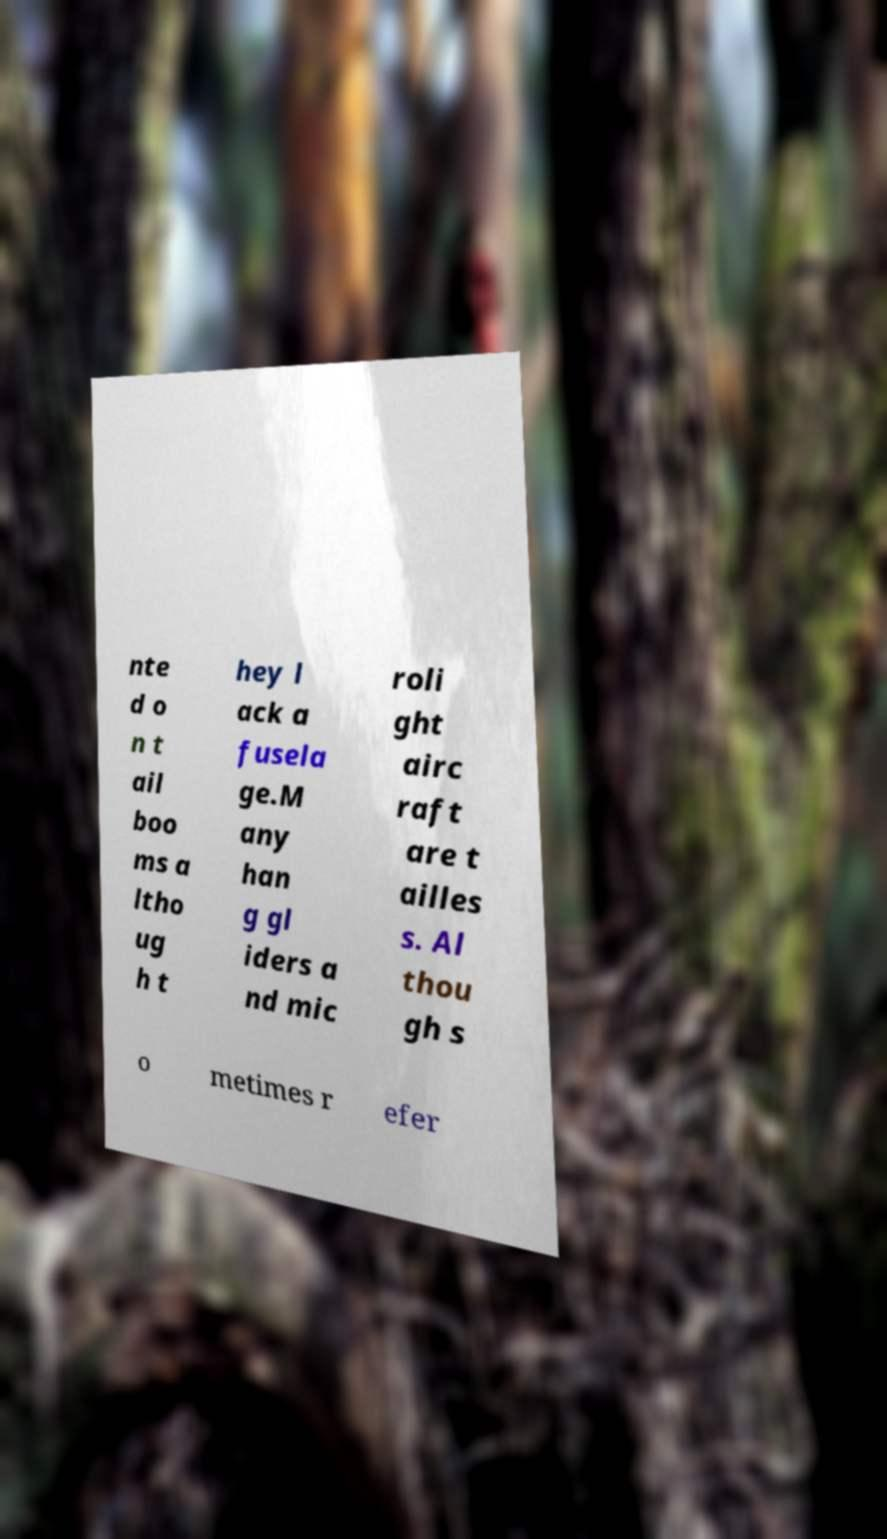Can you read and provide the text displayed in the image?This photo seems to have some interesting text. Can you extract and type it out for me? nte d o n t ail boo ms a ltho ug h t hey l ack a fusela ge.M any han g gl iders a nd mic roli ght airc raft are t ailles s. Al thou gh s o metimes r efer 